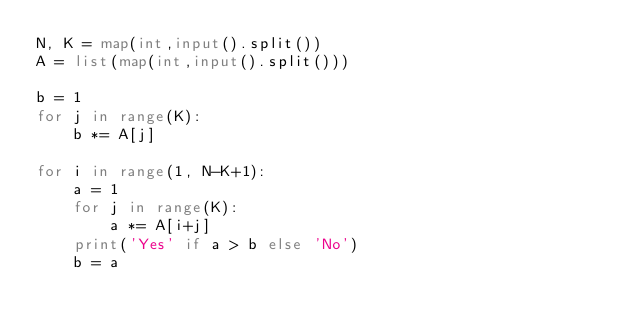<code> <loc_0><loc_0><loc_500><loc_500><_Python_>N, K = map(int,input().split())
A = list(map(int,input().split()))

b = 1
for j in range(K):
    b *= A[j]

for i in range(1, N-K+1):
    a = 1
    for j in range(K):
        a *= A[i+j]
    print('Yes' if a > b else 'No')
    b = a


</code> 